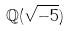Convert formula to latex. <formula><loc_0><loc_0><loc_500><loc_500>\mathbb { Q } ( \sqrt { - 5 } )</formula> 